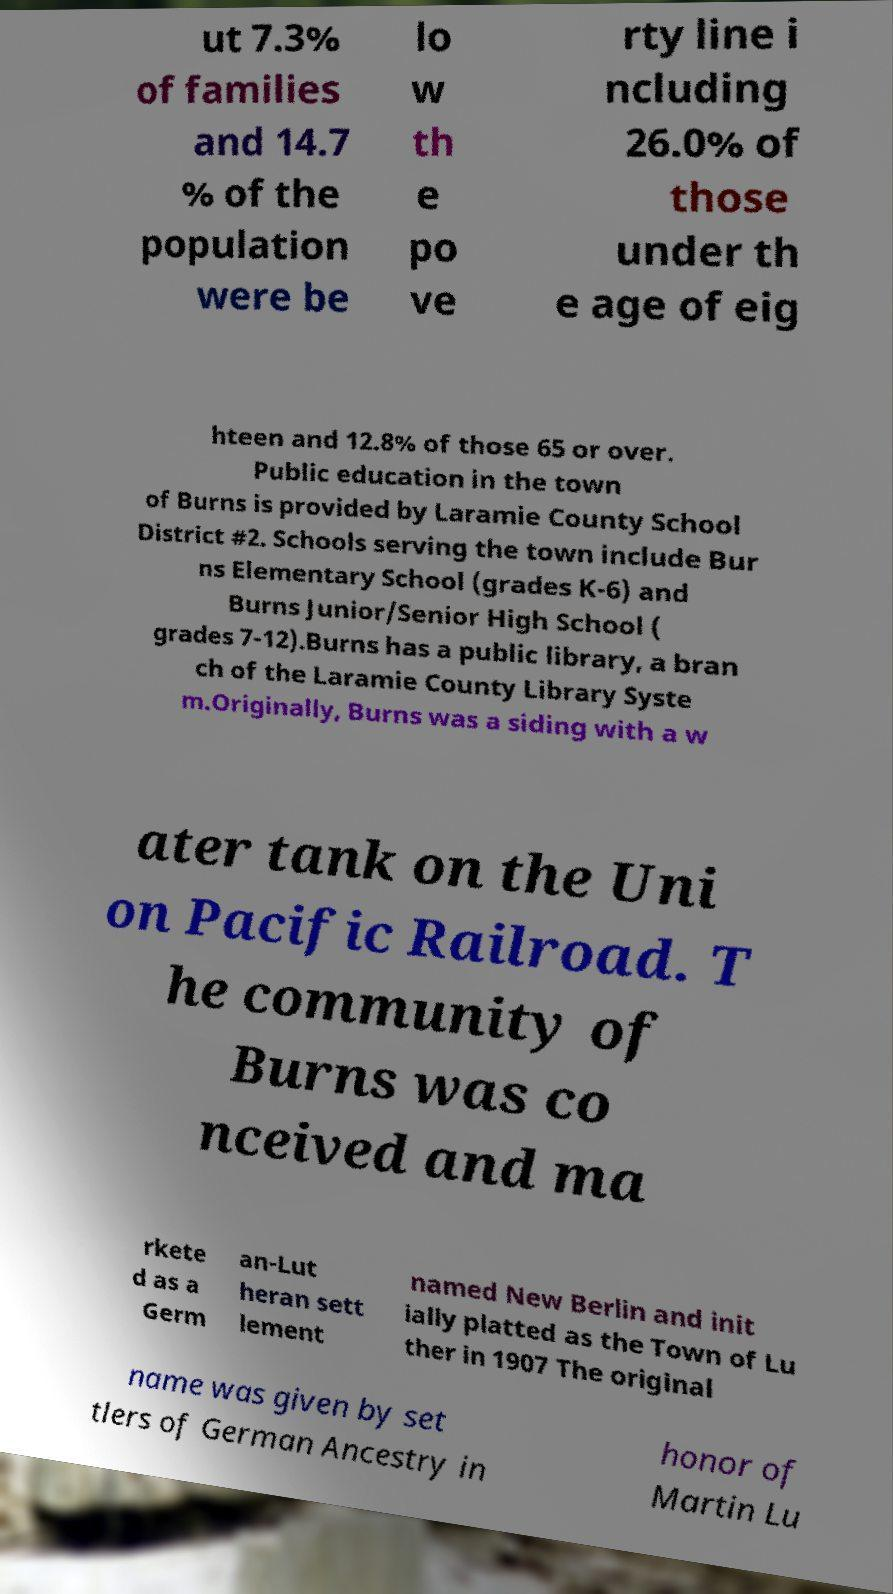Could you extract and type out the text from this image? ut 7.3% of families and 14.7 % of the population were be lo w th e po ve rty line i ncluding 26.0% of those under th e age of eig hteen and 12.8% of those 65 or over. Public education in the town of Burns is provided by Laramie County School District #2. Schools serving the town include Bur ns Elementary School (grades K-6) and Burns Junior/Senior High School ( grades 7-12).Burns has a public library, a bran ch of the Laramie County Library Syste m.Originally, Burns was a siding with a w ater tank on the Uni on Pacific Railroad. T he community of Burns was co nceived and ma rkete d as a Germ an-Lut heran sett lement named New Berlin and init ially platted as the Town of Lu ther in 1907 The original name was given by set tlers of German Ancestry in honor of Martin Lu 